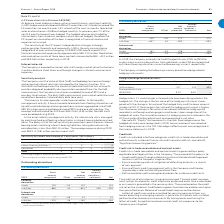According to Lm Ericsson Telephone's financial document, What is the hedge ratio? According to the financial document, 1:1. The relevant text states: "Hedge ratio is 1:1 and changes in forward rate have been designated as the hedged risk. The change in the fair value o..." Also, Is hedge effectiveness recognized in 2019 income statement? According to the financial document, No. The relevant text states: "81 Ericsson | Annual Report 2019 Financials – Notes to the consolidated financial statements 81 Ericsson | Annual Report 2019 Financials – Notes to the consolidated financial statements 81 Ericsson | ..." Also, What is the notional amount in USD for 2019 forward contracts that are less than 1 year? According to the financial document, 517 (in millions). The relevant text states: "Notional Amount (USD millions) 517 176 693 Average forward rate (SEK/USD) 9.13 8.92 –..." Also, can you calculate: What is the difference in notional amount between those less than 1 year and 1-3 years? Based on the calculation: 517-176, the result is 341 (in millions). This is based on the information: "Notional Amount (USD millions) 517 176 693 Average forward rate (SEK/USD) 9.13 8.92 – Notional Amount (USD millions) 517 176 693 Average forward rate (SEK/USD) 9.13 8.92 –..." The key data points involved are: 176, 517. Also, can you calculate: What is the difference in average forward rate between those <1 and 1-3 years? Based on the calculation: 9.13-8.92, the result is 0.21. This is based on the information: ") 517 176 693 Average forward rate (SEK/USD) 9.13 8.92 – lions) 517 176 693 Average forward rate (SEK/USD) 9.13 8.92 –..." The key data points involved are: 8.92, 9.13. Also, can you calculate: What is the percentage constitution of the notional amount of foreign exchange forward contracts that are less than a year among the total notional amount? Based on the calculation: 517/693, the result is 74.6 (percentage). This is based on the information: "Notional Amount (USD millions) 517 176 693 Average forward rate (SEK/USD) 9.13 8.92 – Notional Amount (USD millions) 517 176 693 Average forward rate (SEK/USD) 9.13 8.92 –..." The key data points involved are: 517, 693. 